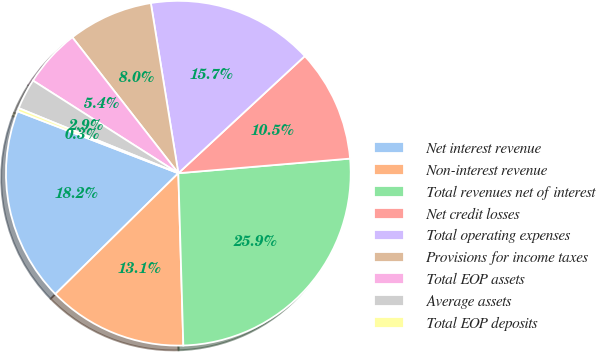Convert chart. <chart><loc_0><loc_0><loc_500><loc_500><pie_chart><fcel>Net interest revenue<fcel>Non-interest revenue<fcel>Total revenues net of interest<fcel>Net credit losses<fcel>Total operating expenses<fcel>Provisions for income taxes<fcel>Total EOP assets<fcel>Average assets<fcel>Total EOP deposits<nl><fcel>18.21%<fcel>13.1%<fcel>25.89%<fcel>10.54%<fcel>15.66%<fcel>7.99%<fcel>5.43%<fcel>2.87%<fcel>0.31%<nl></chart> 